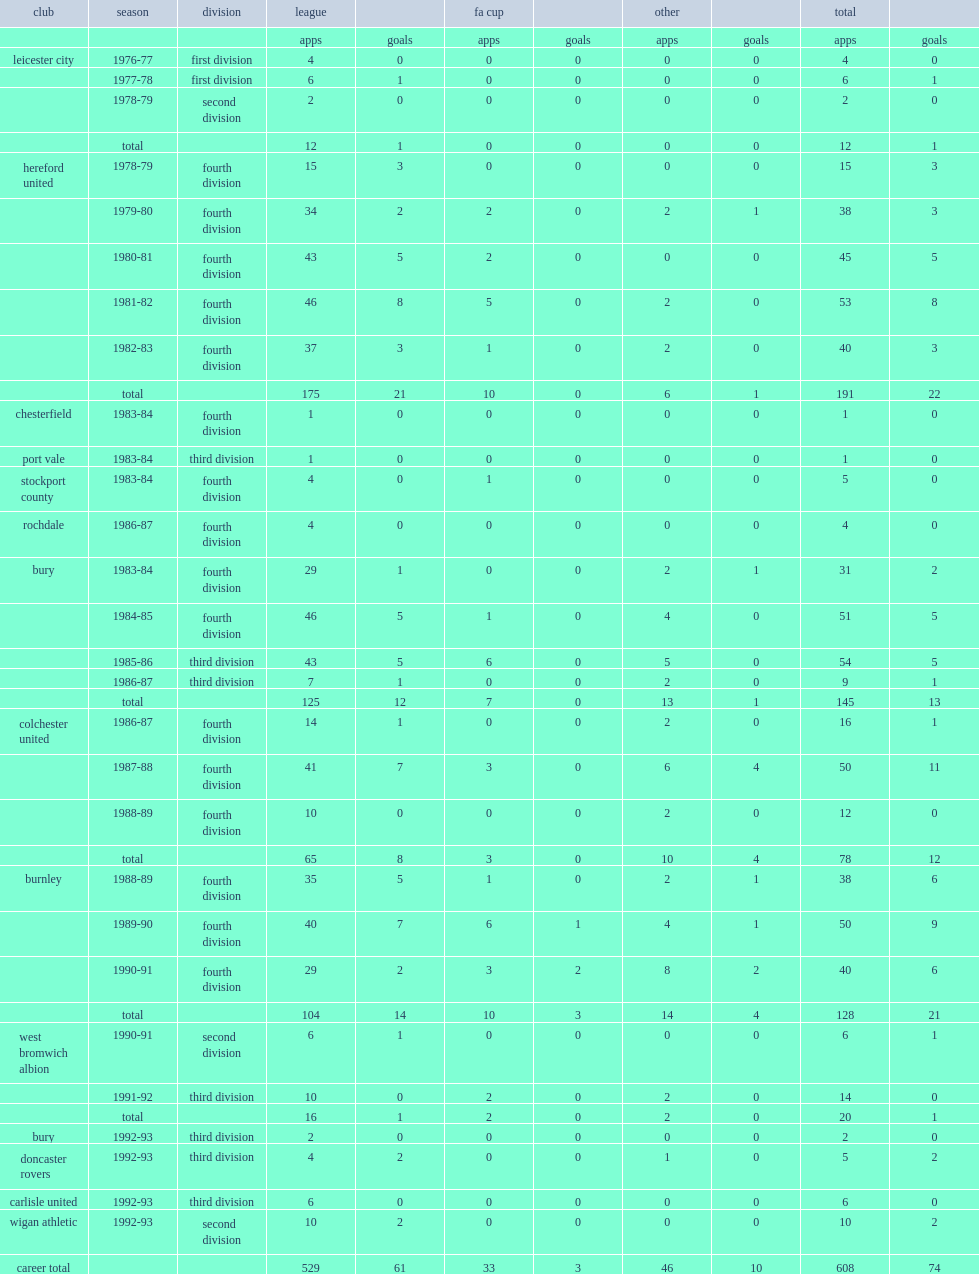What was the number of league appearances made by winston white in a 17-year career? 529.0. 